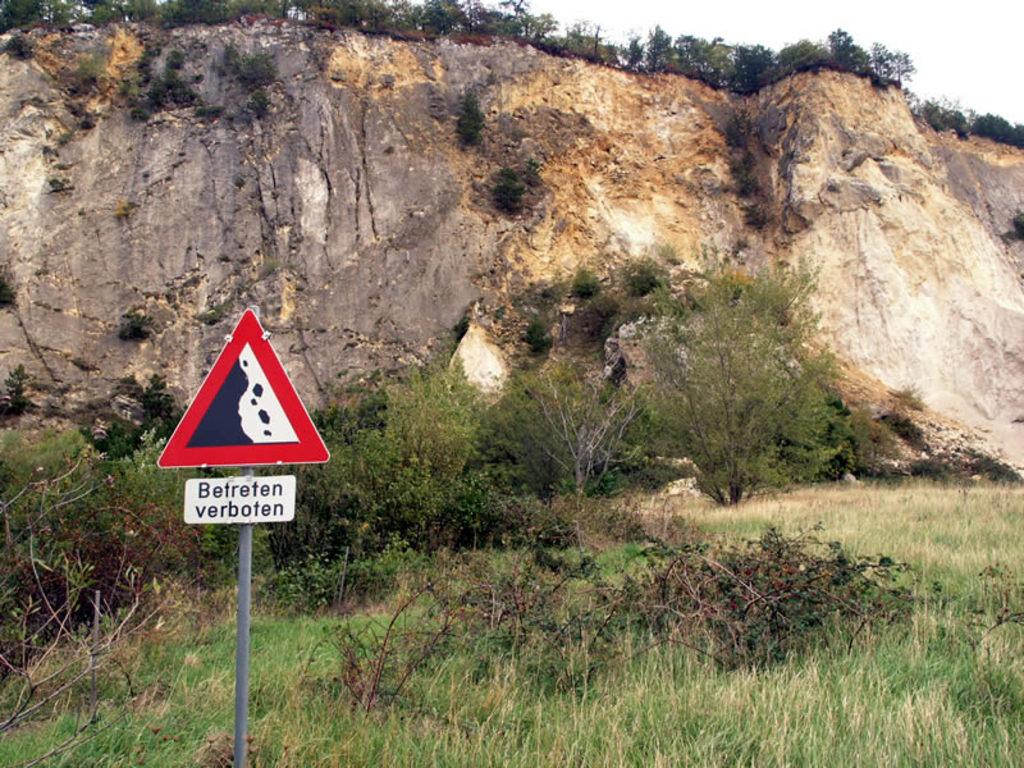What is the sign warning you of?
Your answer should be very brief. Betreten verboten. 